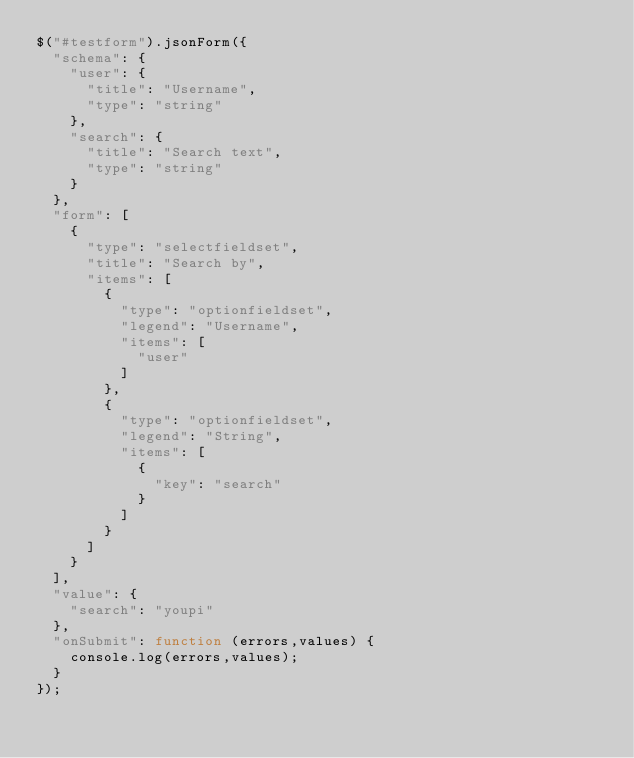<code> <loc_0><loc_0><loc_500><loc_500><_JavaScript_>$("#testform").jsonForm({
  "schema": {
    "user": {
      "title": "Username",
      "type": "string"
    },
    "search": {
      "title": "Search text",
      "type": "string"
    }
  },
  "form": [
    {
      "type": "selectfieldset",
      "title": "Search by",
      "items": [
        {
          "type": "optionfieldset",
          "legend": "Username",
          "items": [
            "user"
          ]
        },
        {
          "type": "optionfieldset",
          "legend": "String",
          "items": [
            {
              "key": "search"
            }
          ]
        }
      ]
    }
  ],
  "value": {
    "search": "youpi"
  },
  "onSubmit": function (errors,values) {
    console.log(errors,values);
  }
});
</code> 